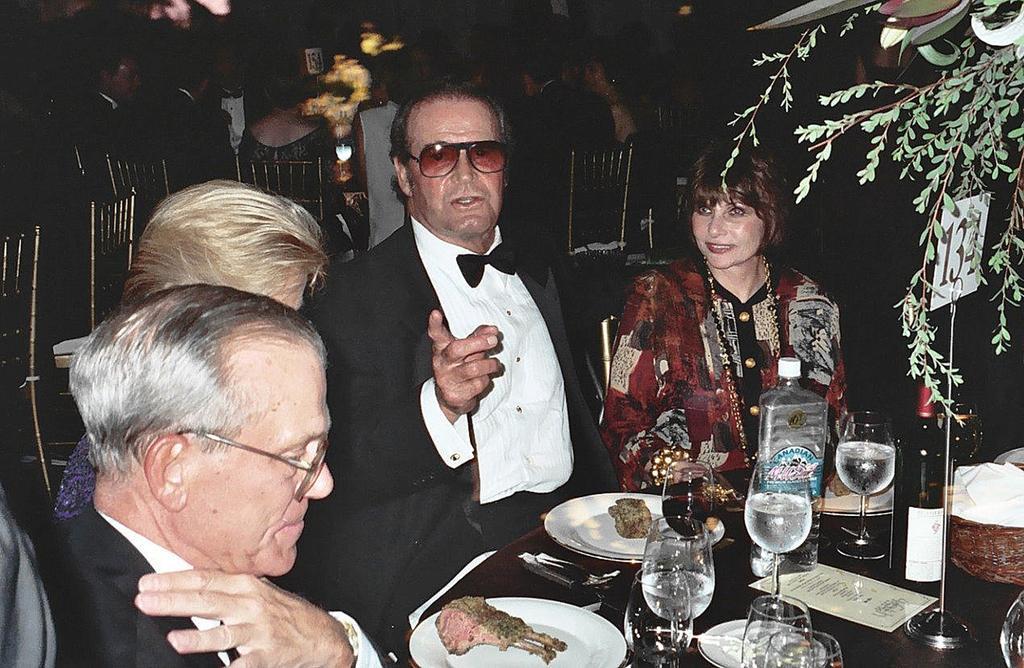Could you give a brief overview of what you see in this image? In this image we can see a few people are sitting on the chairs, in front of them there is a table, on that there are food items on the plate, there are glasses, there is a bottle, there is a board on the stand with numbers on it, also we can see a card with text on it, there is a houseplant, and the background is dark. 